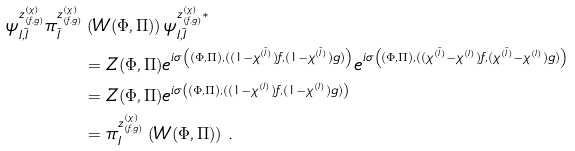Convert formula to latex. <formula><loc_0><loc_0><loc_500><loc_500>\psi ^ { z ^ { ( \chi ) } _ { ( f , g ) } } _ { I , \tilde { I } } \pi ^ { z ^ { ( \chi ) } _ { ( f , g ) } } _ { \tilde { I } } & \left ( W ( \Phi , \Pi ) \right ) \psi ^ { z ^ { ( \chi ) } _ { ( f , g ) } * } _ { I , \tilde { I } } \\ & = Z ( \Phi , \Pi ) e ^ { i \sigma \left ( ( \Phi , \Pi ) , ( ( 1 - \chi ^ { ( \tilde { I } ) } ) f , ( 1 - \chi ^ { ( \tilde { I } ) } ) g ) \right ) } e ^ { i \sigma \left ( ( \Phi , \Pi ) , ( ( \chi ^ { ( \tilde { I } ) } - \chi ^ { ( I ) } ) f , ( \chi ^ { ( \tilde { I } ) } - \chi ^ { ( I ) } ) g ) \right ) } \\ & = Z ( \Phi , \Pi ) e ^ { i \sigma \left ( ( \Phi , \Pi ) , ( ( 1 - \chi ^ { ( I ) } ) f , ( 1 - \chi ^ { ( I ) } ) g ) \right ) } \\ & = \pi ^ { z ^ { ( \chi ) } _ { ( f , g ) } } _ { I } \left ( W ( \Phi , \Pi ) \right ) \, .</formula> 